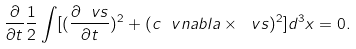Convert formula to latex. <formula><loc_0><loc_0><loc_500><loc_500>\frac { \partial } { \partial t } \frac { 1 } { 2 } \int [ ( \frac { \partial \ v s } { \partial t } ) ^ { 2 } + ( c \ v n a b l a \times \ v s ) ^ { 2 } ] d ^ { 3 } x = 0 .</formula> 